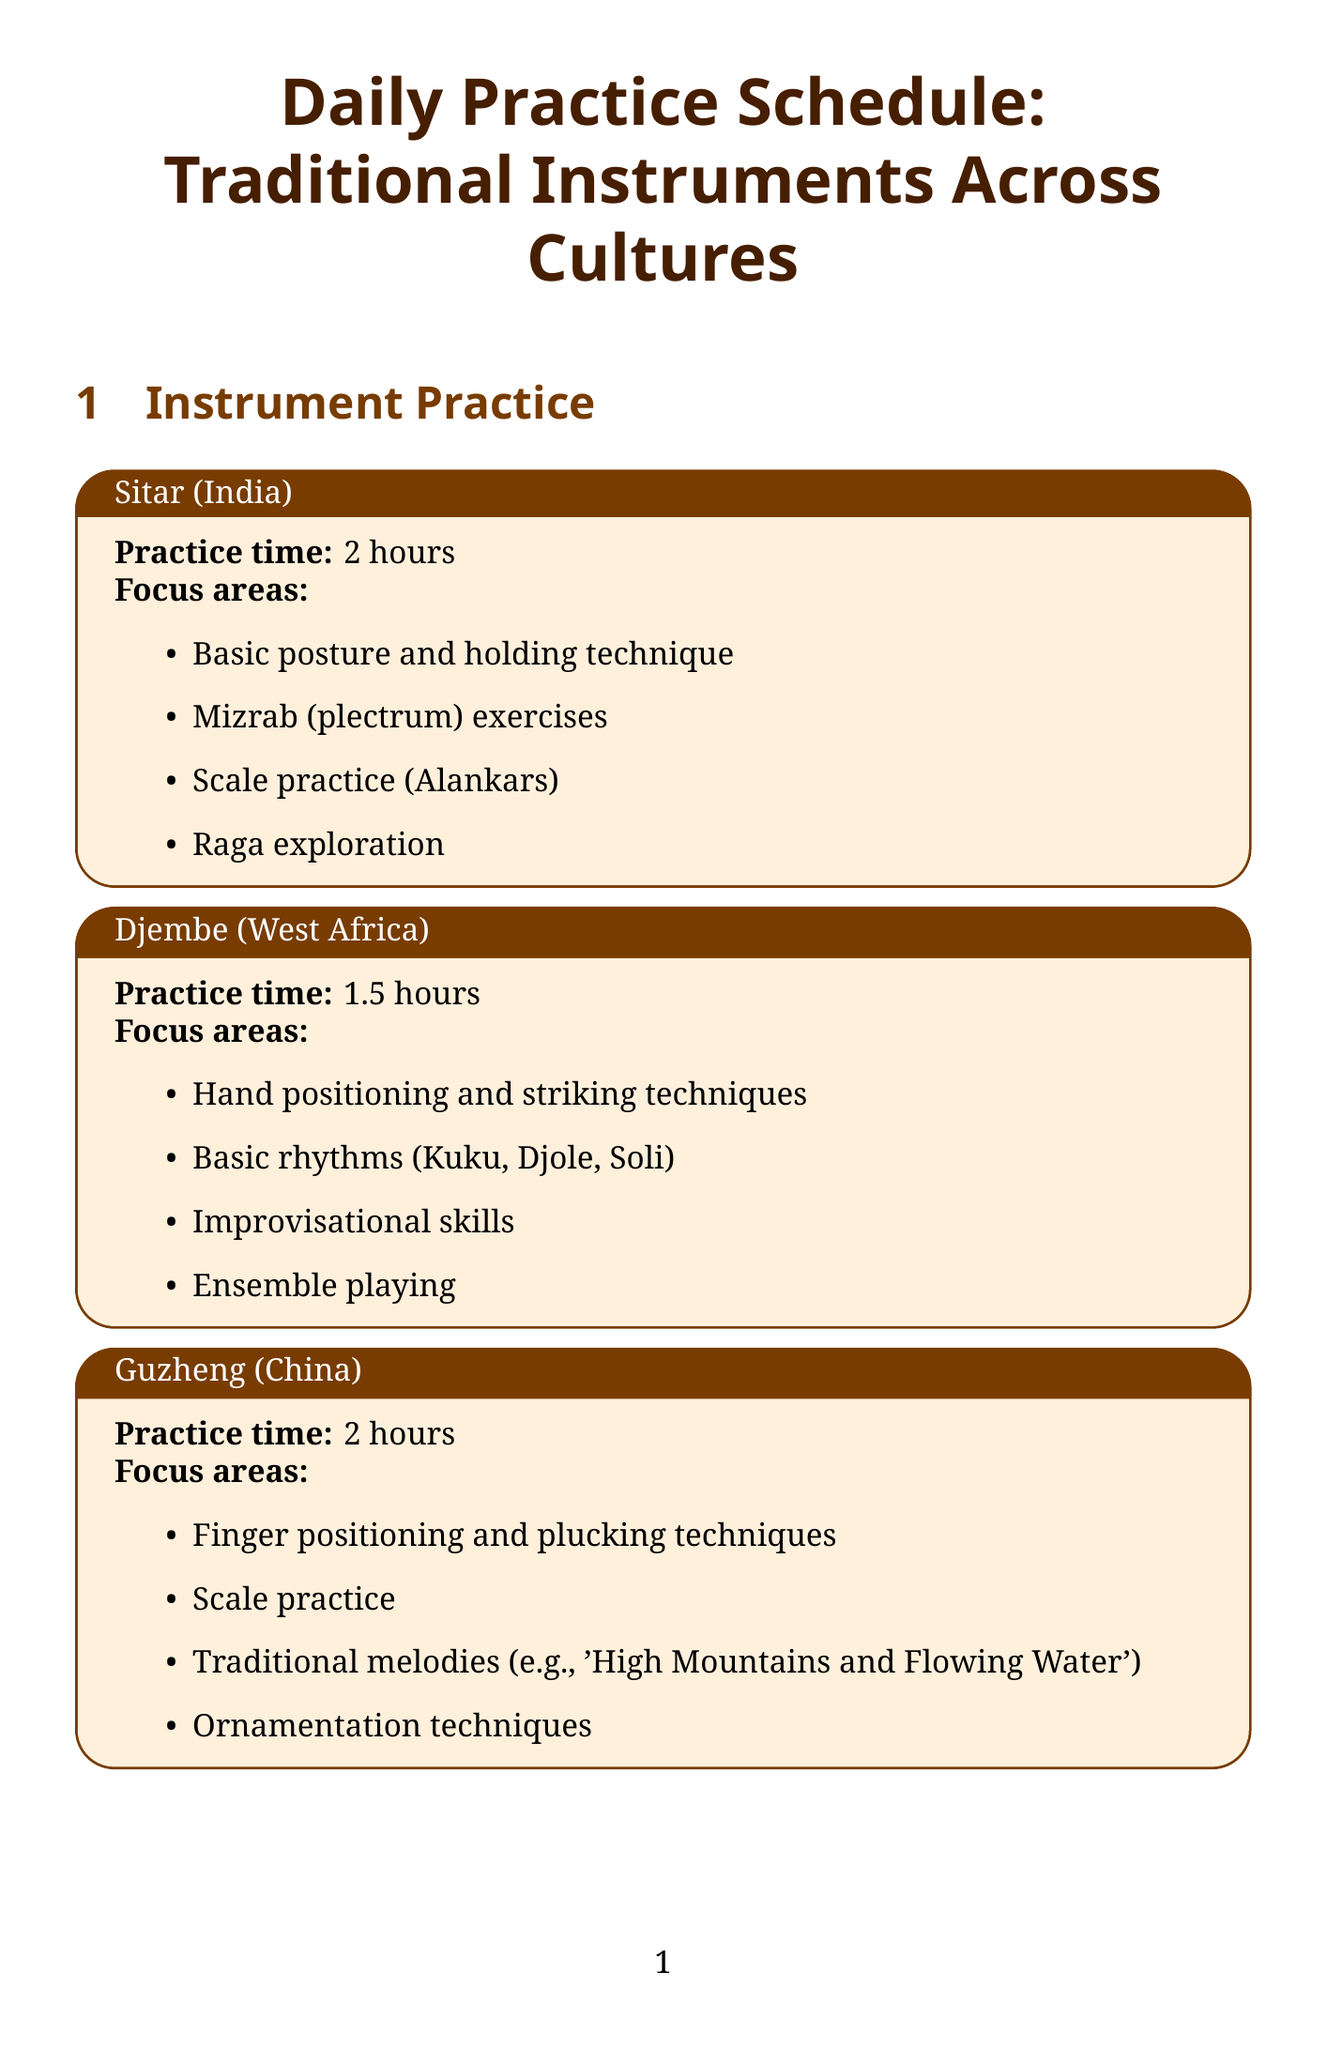What is the practice time for the Sitar? The practice time for the Sitar is listed under the Sitar section as 2 hours.
Answer: 2 hours What cultural aspect involves analyzing video recordings? The document specifies that analyzing video recordings pertains to the social function in the cultural aspects study.
Answer: Social function How long is the focused instrument practice session? According to the daily structure section, the focused instrument practice duration is indicated to be 2 hours.
Answer: 2 hours What traditional melody is mentioned for the Guzheng? The document mentions 'High Mountains and Flowing Water' as a traditional melody for the Guzheng under its focus areas.
Answer: High Mountains and Flowing Water Which online course is offered by Berklee College of Music? The document lists the online course 'World Music' as being offered by Berklee College of Music in the resources section.
Answer: World Music Which instrument requires 1.5 hours of practice? The Djembe and Oud are both mentioned with a practice time of 1.5 hours in their respective sections.
Answer: Djembe, Oud What method is used to study emotional expression through music? The document states that emotional expression through music is studied through interviews with master musicians.
Answer: Interviews with master musicians What time is dedicated to warm-up exercises in the daily schedule? The document specifies that morning time is allocated for warm-up exercises and technique practice.
Answer: Morning What types of resources are listed in the document? The resources section includes books, journals, and online courses as types of resources.
Answer: Books, Journals, Online courses 